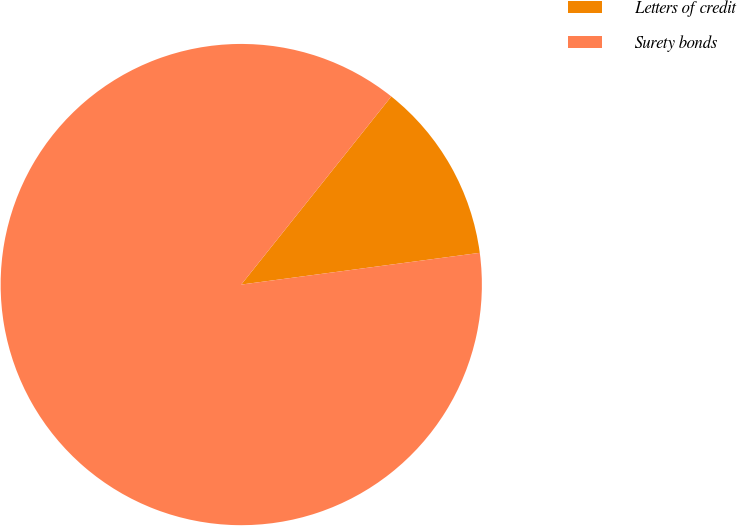Convert chart to OTSL. <chart><loc_0><loc_0><loc_500><loc_500><pie_chart><fcel>Letters of credit<fcel>Surety bonds<nl><fcel>12.18%<fcel>87.82%<nl></chart> 